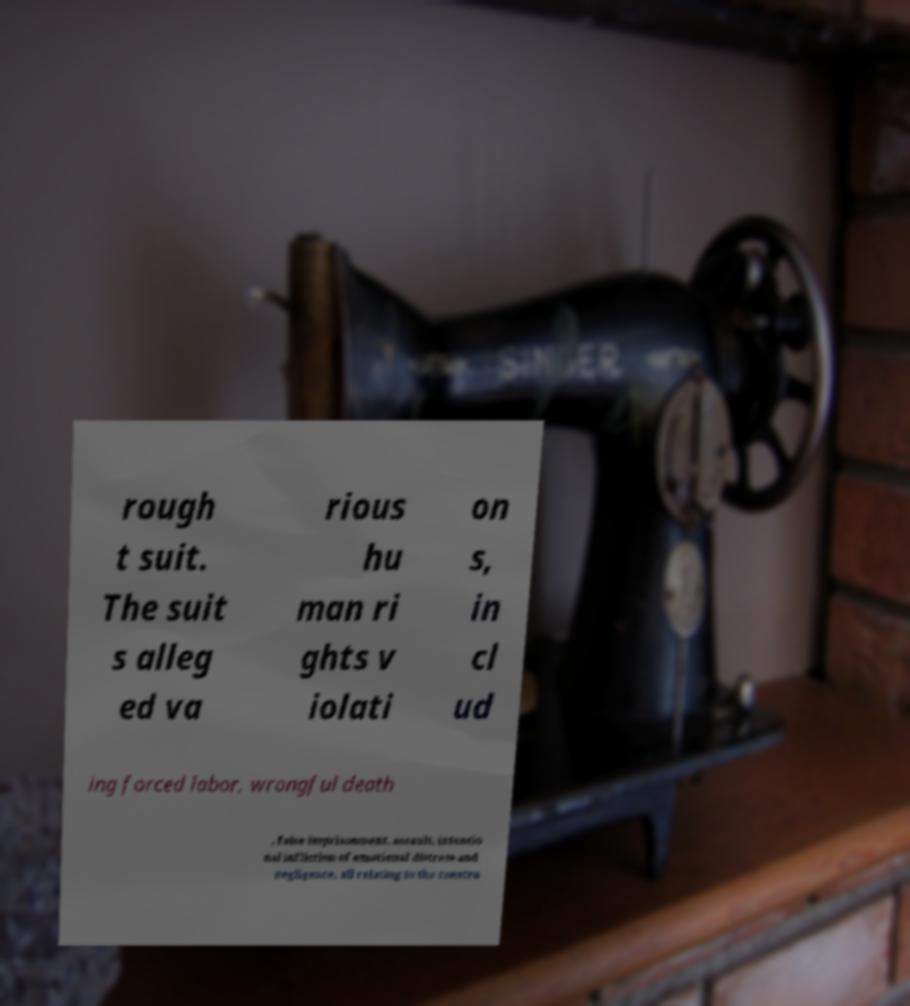There's text embedded in this image that I need extracted. Can you transcribe it verbatim? rough t suit. The suit s alleg ed va rious hu man ri ghts v iolati on s, in cl ud ing forced labor, wrongful death , false imprisonment, assault, intentio nal infliction of emotional distress and negligence, all relating to the constru 